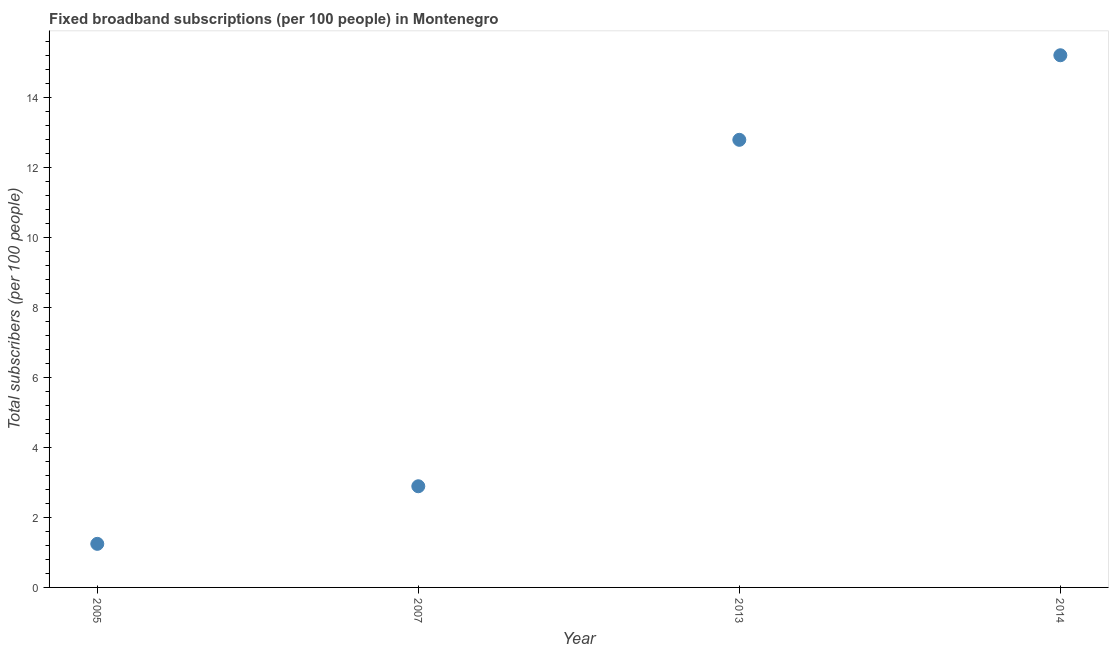What is the total number of fixed broadband subscriptions in 2013?
Offer a terse response. 12.78. Across all years, what is the maximum total number of fixed broadband subscriptions?
Your response must be concise. 15.2. Across all years, what is the minimum total number of fixed broadband subscriptions?
Offer a terse response. 1.24. What is the sum of the total number of fixed broadband subscriptions?
Your response must be concise. 32.12. What is the difference between the total number of fixed broadband subscriptions in 2005 and 2013?
Your answer should be compact. -11.54. What is the average total number of fixed broadband subscriptions per year?
Provide a succinct answer. 8.03. What is the median total number of fixed broadband subscriptions?
Provide a succinct answer. 7.84. In how many years, is the total number of fixed broadband subscriptions greater than 12.4 ?
Make the answer very short. 2. What is the ratio of the total number of fixed broadband subscriptions in 2005 to that in 2014?
Give a very brief answer. 0.08. Is the total number of fixed broadband subscriptions in 2007 less than that in 2013?
Ensure brevity in your answer.  Yes. What is the difference between the highest and the second highest total number of fixed broadband subscriptions?
Your answer should be very brief. 2.42. Is the sum of the total number of fixed broadband subscriptions in 2005 and 2013 greater than the maximum total number of fixed broadband subscriptions across all years?
Ensure brevity in your answer.  No. What is the difference between the highest and the lowest total number of fixed broadband subscriptions?
Your answer should be very brief. 13.96. In how many years, is the total number of fixed broadband subscriptions greater than the average total number of fixed broadband subscriptions taken over all years?
Provide a succinct answer. 2. How many dotlines are there?
Your answer should be very brief. 1. What is the difference between two consecutive major ticks on the Y-axis?
Your response must be concise. 2. Does the graph contain grids?
Offer a terse response. No. What is the title of the graph?
Offer a terse response. Fixed broadband subscriptions (per 100 people) in Montenegro. What is the label or title of the Y-axis?
Provide a succinct answer. Total subscribers (per 100 people). What is the Total subscribers (per 100 people) in 2005?
Offer a terse response. 1.24. What is the Total subscribers (per 100 people) in 2007?
Keep it short and to the point. 2.89. What is the Total subscribers (per 100 people) in 2013?
Offer a terse response. 12.78. What is the Total subscribers (per 100 people) in 2014?
Your answer should be compact. 15.2. What is the difference between the Total subscribers (per 100 people) in 2005 and 2007?
Keep it short and to the point. -1.64. What is the difference between the Total subscribers (per 100 people) in 2005 and 2013?
Your answer should be very brief. -11.54. What is the difference between the Total subscribers (per 100 people) in 2005 and 2014?
Your answer should be compact. -13.96. What is the difference between the Total subscribers (per 100 people) in 2007 and 2013?
Give a very brief answer. -9.89. What is the difference between the Total subscribers (per 100 people) in 2007 and 2014?
Your response must be concise. -12.31. What is the difference between the Total subscribers (per 100 people) in 2013 and 2014?
Your response must be concise. -2.42. What is the ratio of the Total subscribers (per 100 people) in 2005 to that in 2007?
Your response must be concise. 0.43. What is the ratio of the Total subscribers (per 100 people) in 2005 to that in 2013?
Your response must be concise. 0.1. What is the ratio of the Total subscribers (per 100 people) in 2005 to that in 2014?
Your answer should be very brief. 0.08. What is the ratio of the Total subscribers (per 100 people) in 2007 to that in 2013?
Provide a succinct answer. 0.23. What is the ratio of the Total subscribers (per 100 people) in 2007 to that in 2014?
Offer a very short reply. 0.19. What is the ratio of the Total subscribers (per 100 people) in 2013 to that in 2014?
Provide a succinct answer. 0.84. 